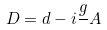Convert formula to latex. <formula><loc_0><loc_0><loc_500><loc_500>D = d - i \frac { g } { } A</formula> 